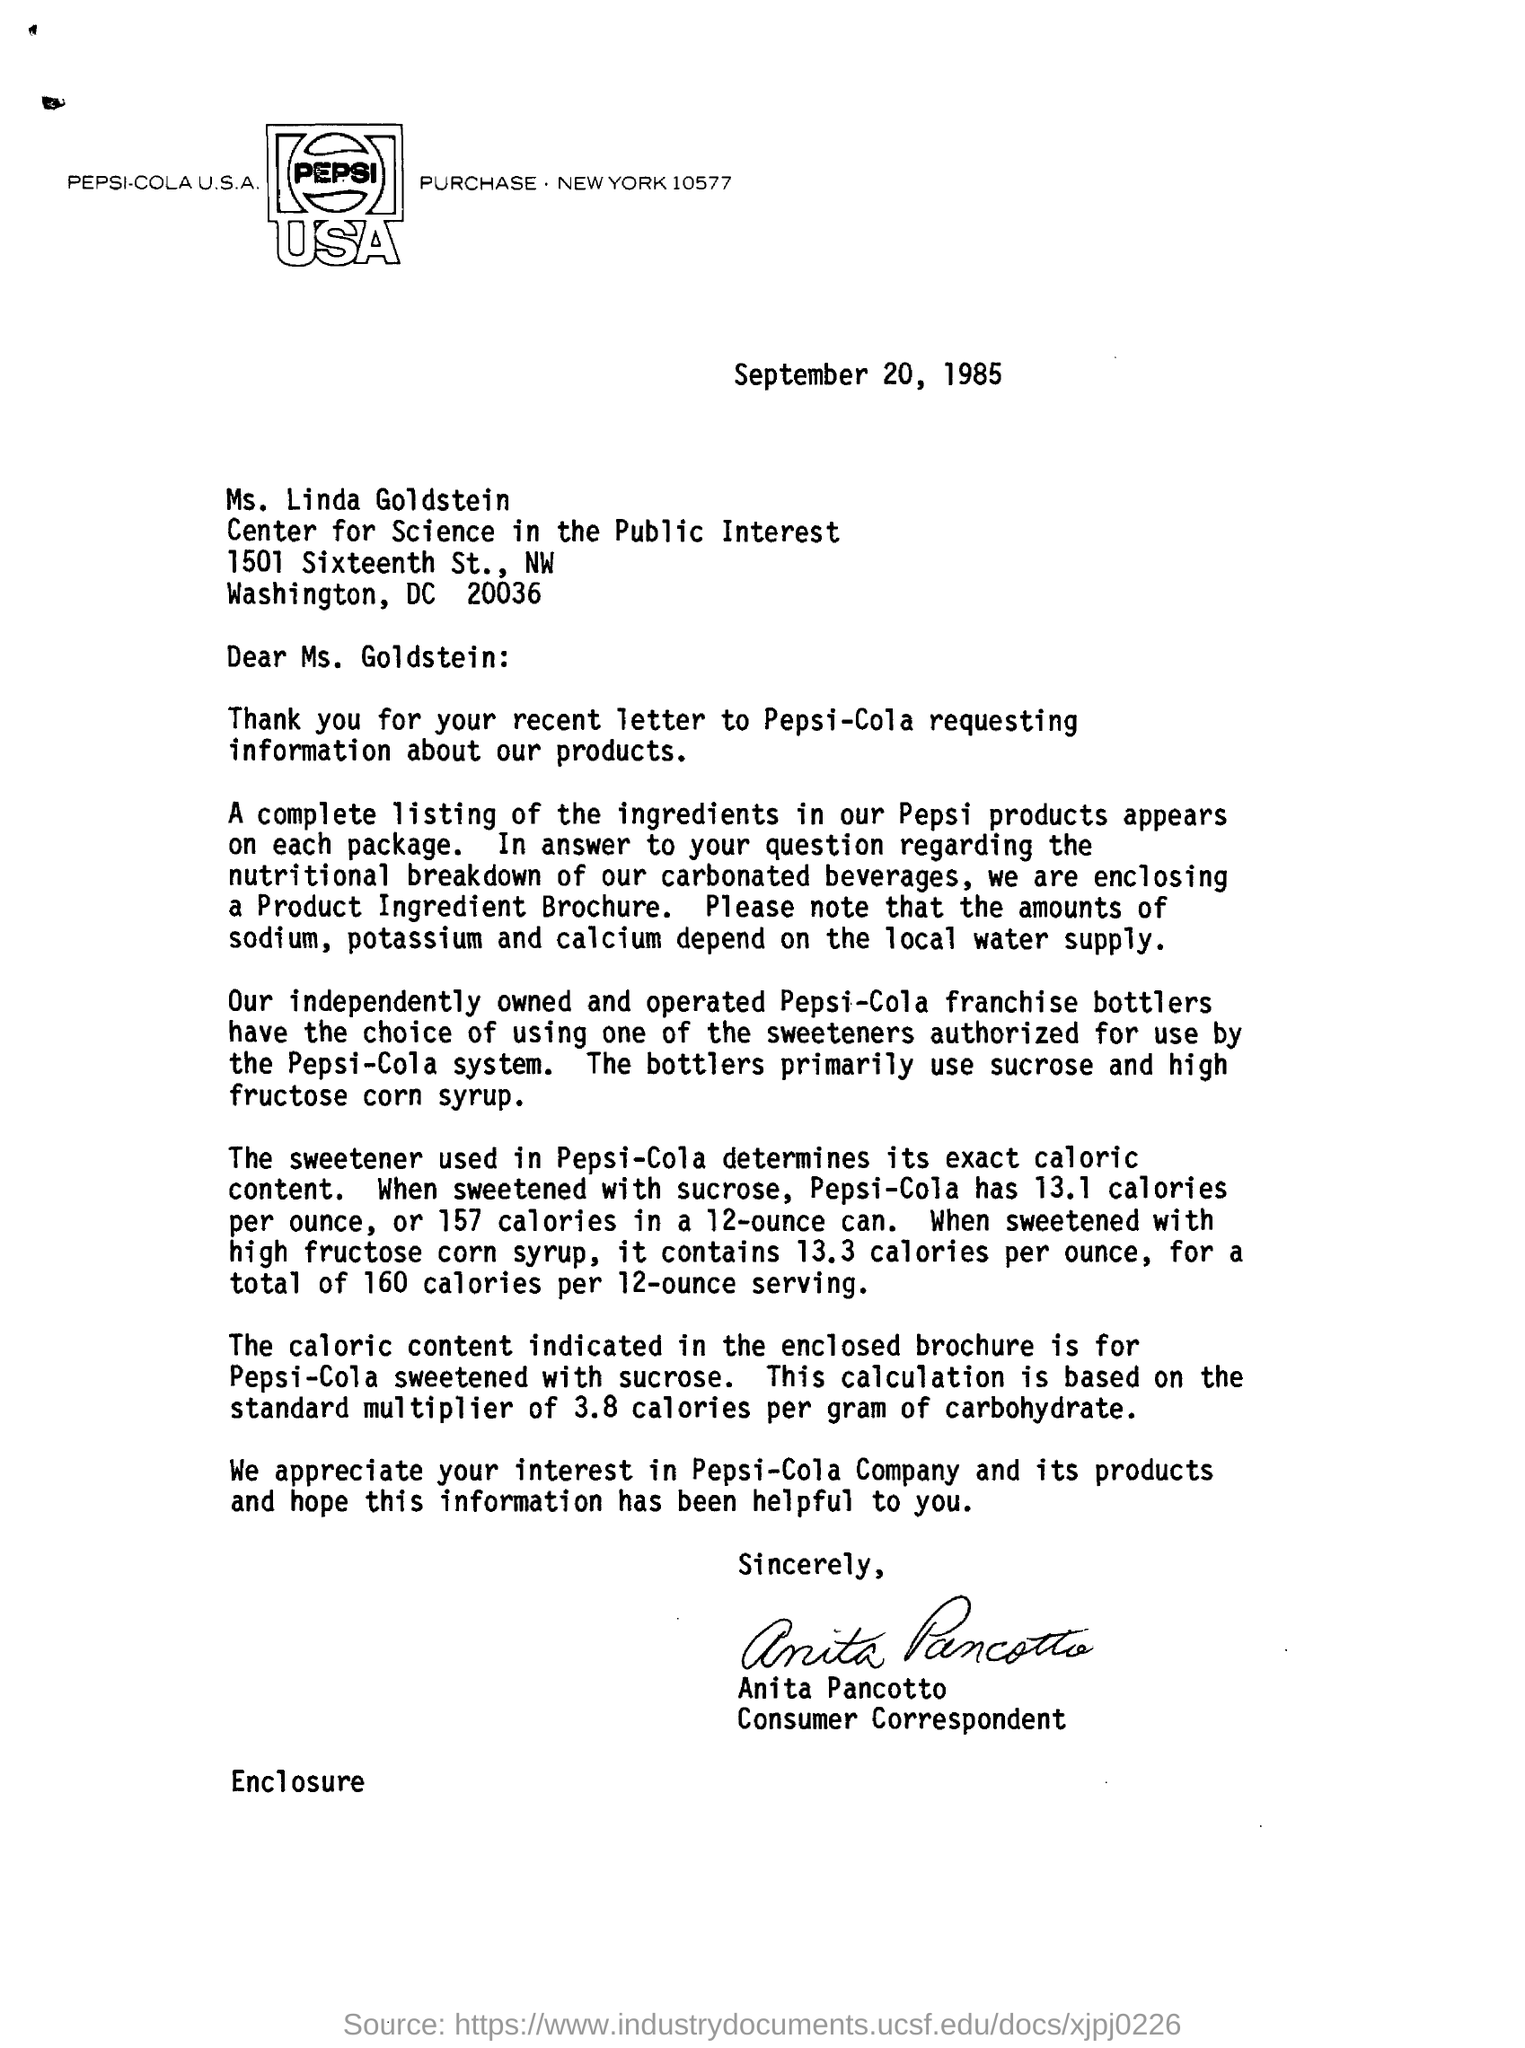Mention a couple of crucial points in this snapshot. The date mentioned is September 20, 1985. The levels of sodium, potassium, and calcium in an area depend on the local water supply. The letter is addressed to Ms. Goldstein. The complete listing of ingredients in Pepsi products can be found on each package of the product. 